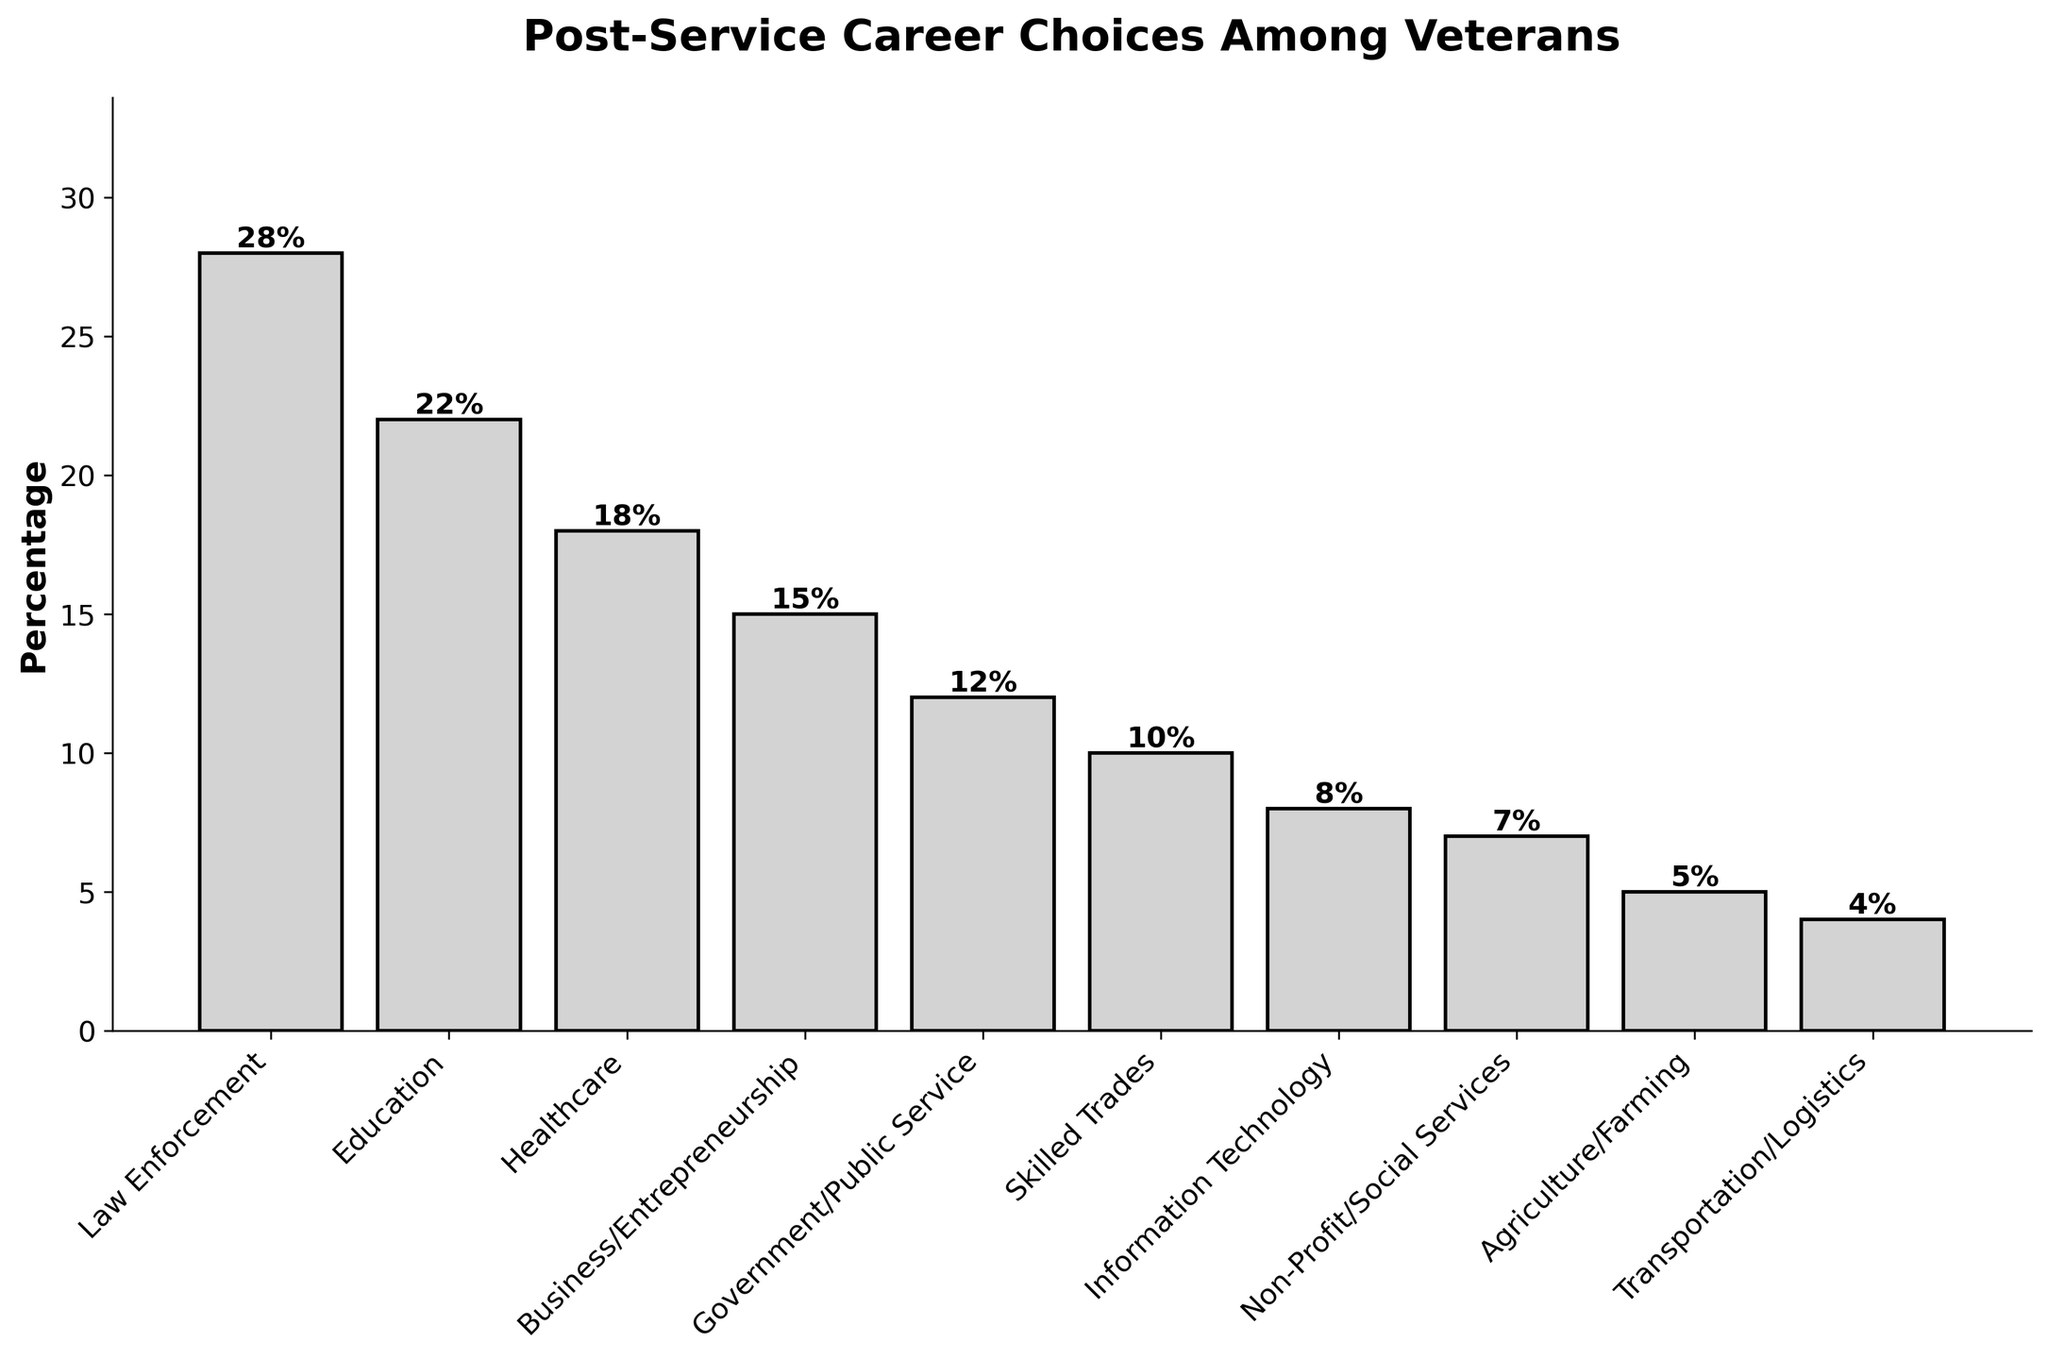What career choice has the highest percentage among veterans from our area? By looking at the heights of the bars, the tallest bar corresponds to the career choice with the highest percentage. Law Enforcement has the highest bar.
Answer: Law Enforcement Which career has a lower percentage: Healthcare or Education? We compare the heights of the bars for Healthcare and Education. Healthcare is at 18% and Education is at 22%. Healthcare has a lower percentage.
Answer: Healthcare How many career choices have more than 15% of veterans? Count the bars that have heights greater than 15%. Law Enforcement (28%), Education (22%), and Healthcare (18%) meet this criterion.
Answer: 3 What is the total percentage of veterans in Law Enforcement, Education, and Healthcare? Add the percentages for these careers: 28% (Law Enforcement) + 22% (Education) + 18% (Healthcare). 28 + 22 + 18 = 68.
Answer: 68% Is the percentage of veterans in Business/Entrepreneurship greater than in Government/Public Service? Compare the heights of the bars for Business/Entrepreneurship (15%) and Government/Public Service (12%). Business/Entrepreneurship is higher.
Answer: Yes What is the difference in percentage between Skilled Trades and Information Technology? Subtract the percentage of Information Technology from Skilled Trades: 10% (Skilled Trades) - 8% (Information Technology). 10 - 8 = 2.
Answer: 2% Which career choice has the smallest percentage? The bar with the lowest height represents the career choice with the smallest percentage. Transportation/Logistics has the smallest bar at 4%.
Answer: Transportation/Logistics What is the combined percentage for Non-Profit/Social Services and Agriculture/Farming? Add the percentages for these careers: 7% (Non-Profit/Social Services) + 5% (Agriculture/Farming). 7 + 5 = 12.
Answer: 12% How much more popular is Law Enforcement compared to Information Technology? Subtract the percentage of Information Technology from Law Enforcement: 28% (Law Enforcement) - 8% (Information Technology). 28 - 8 = 20.
Answer: 20% Which career choices fall under 10%? Identify bars with heights less than 10%. Information Technology (8%), Non-Profit/Social Services (7%), Agriculture/Farming (5%), and Transportation/Logistics (4%) fall under this range.
Answer: Information Technology, Non-Profit/Social Services, Agriculture/Farming, Transportation/Logistics 